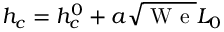Convert formula to latex. <formula><loc_0><loc_0><loc_500><loc_500>h _ { c } = h _ { c } ^ { 0 } + a \sqrt { W e } L _ { 0 }</formula> 